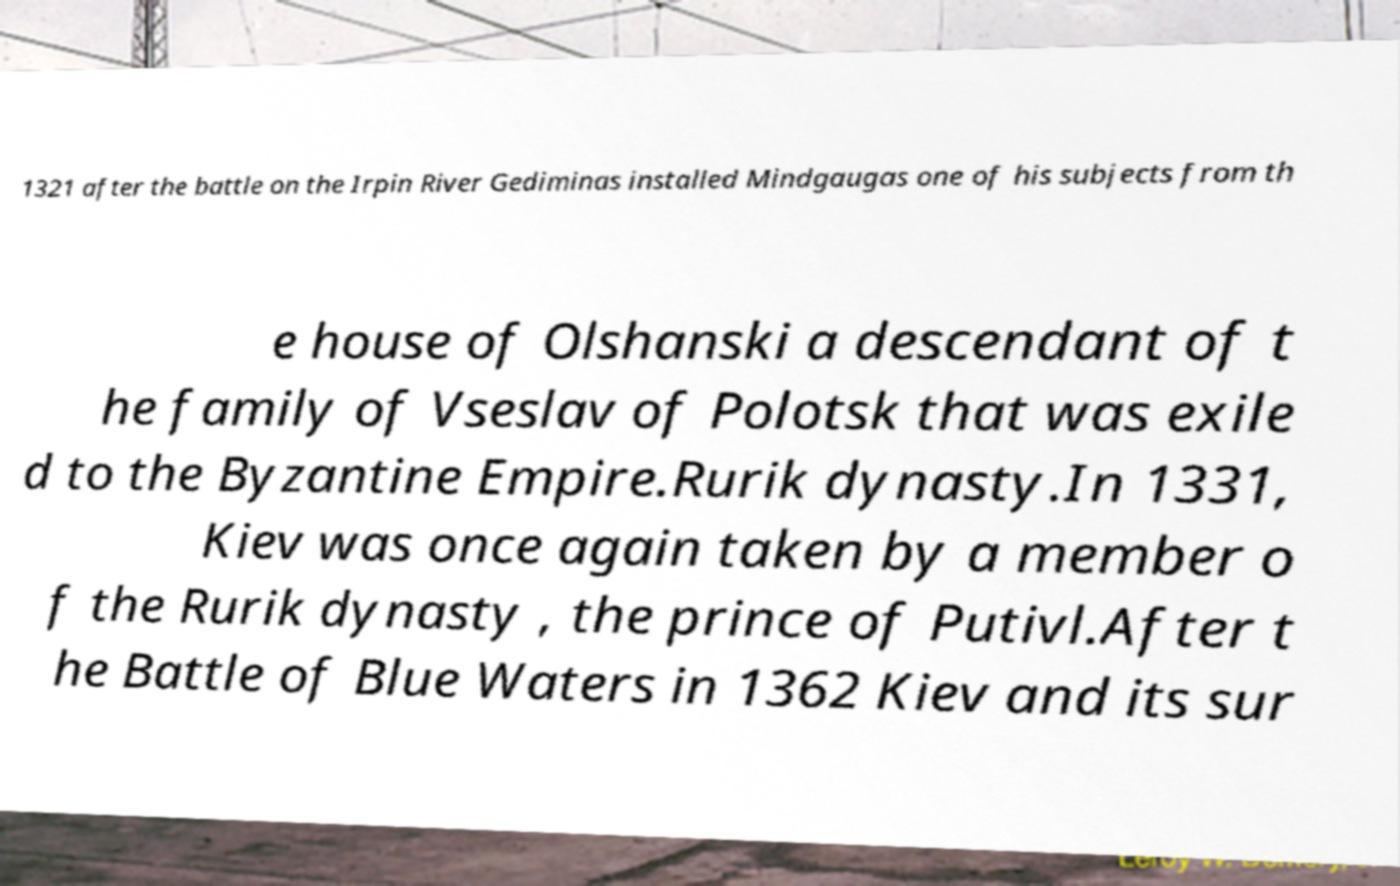Could you extract and type out the text from this image? 1321 after the battle on the Irpin River Gediminas installed Mindgaugas one of his subjects from th e house of Olshanski a descendant of t he family of Vseslav of Polotsk that was exile d to the Byzantine Empire.Rurik dynasty.In 1331, Kiev was once again taken by a member o f the Rurik dynasty , the prince of Putivl.After t he Battle of Blue Waters in 1362 Kiev and its sur 